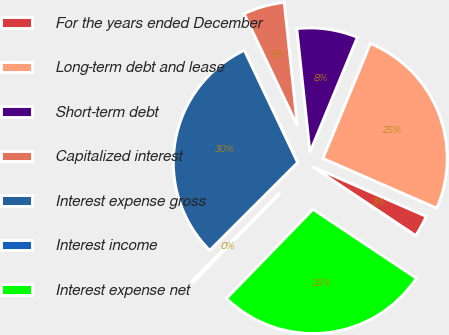<chart> <loc_0><loc_0><loc_500><loc_500><pie_chart><fcel>For the years ended December<fcel>Long-term debt and lease<fcel>Short-term debt<fcel>Capitalized interest<fcel>Interest expense gross<fcel>Interest income<fcel>Interest expense net<nl><fcel>2.81%<fcel>25.33%<fcel>7.92%<fcel>5.36%<fcel>30.44%<fcel>0.25%<fcel>27.89%<nl></chart> 